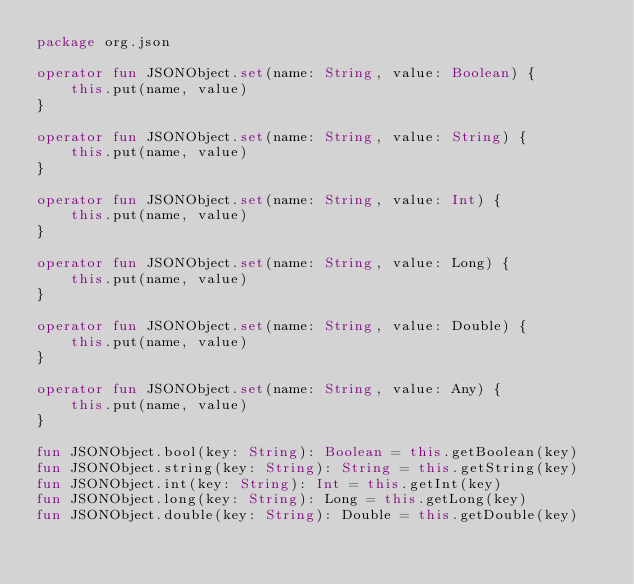<code> <loc_0><loc_0><loc_500><loc_500><_Kotlin_>package org.json

operator fun JSONObject.set(name: String, value: Boolean) {
    this.put(name, value)
}

operator fun JSONObject.set(name: String, value: String) {
    this.put(name, value)
}

operator fun JSONObject.set(name: String, value: Int) {
    this.put(name, value)
}

operator fun JSONObject.set(name: String, value: Long) {
    this.put(name, value)
}

operator fun JSONObject.set(name: String, value: Double) {
    this.put(name, value)
}

operator fun JSONObject.set(name: String, value: Any) {
    this.put(name, value)
}

fun JSONObject.bool(key: String): Boolean = this.getBoolean(key)
fun JSONObject.string(key: String): String = this.getString(key)
fun JSONObject.int(key: String): Int = this.getInt(key)
fun JSONObject.long(key: String): Long = this.getLong(key)
fun JSONObject.double(key: String): Double = this.getDouble(key)

</code> 